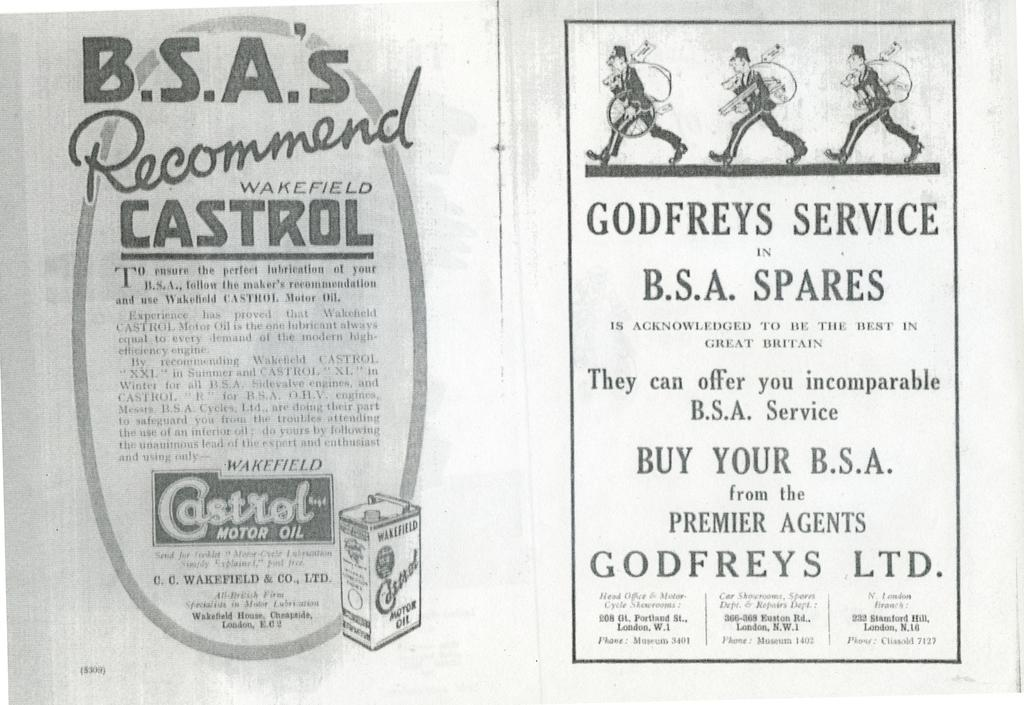What can be found in the image that contains written information? There is text written in the image. Where are the cartoon characters located in the image? The cartoon characters are on the top right side of the image. Is there a heart-shaped object visible on the stage in the image? There is no stage or heart-shaped object present in the image. What type of bag can be seen in the image? There is no bag present in the image. 